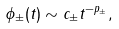<formula> <loc_0><loc_0><loc_500><loc_500>\phi _ { \pm } ( t ) \sim c _ { \pm } t ^ { - p _ { \pm } } ,</formula> 